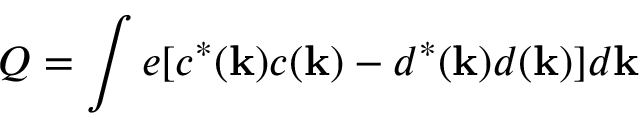<formula> <loc_0><loc_0><loc_500><loc_500>Q = \int e [ c ^ { \ast } ( { k } ) c ( { k } ) - d ^ { \ast } ( { k } ) d ( { k } ) ] d { k }</formula> 